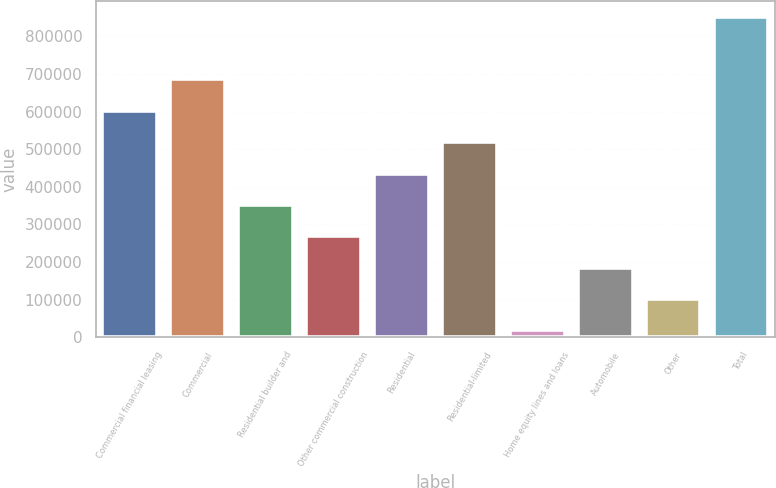Convert chart to OTSL. <chart><loc_0><loc_0><loc_500><loc_500><bar_chart><fcel>Commercial financial leasing<fcel>Commercial<fcel>Residential builder and<fcel>Other commercial construction<fcel>Residential<fcel>Residential-limited<fcel>Home equity lines and loans<fcel>Automobile<fcel>Other<fcel>Total<nl><fcel>601844<fcel>685238<fcel>351661<fcel>268266<fcel>435055<fcel>518449<fcel>18083<fcel>184872<fcel>101477<fcel>852027<nl></chart> 